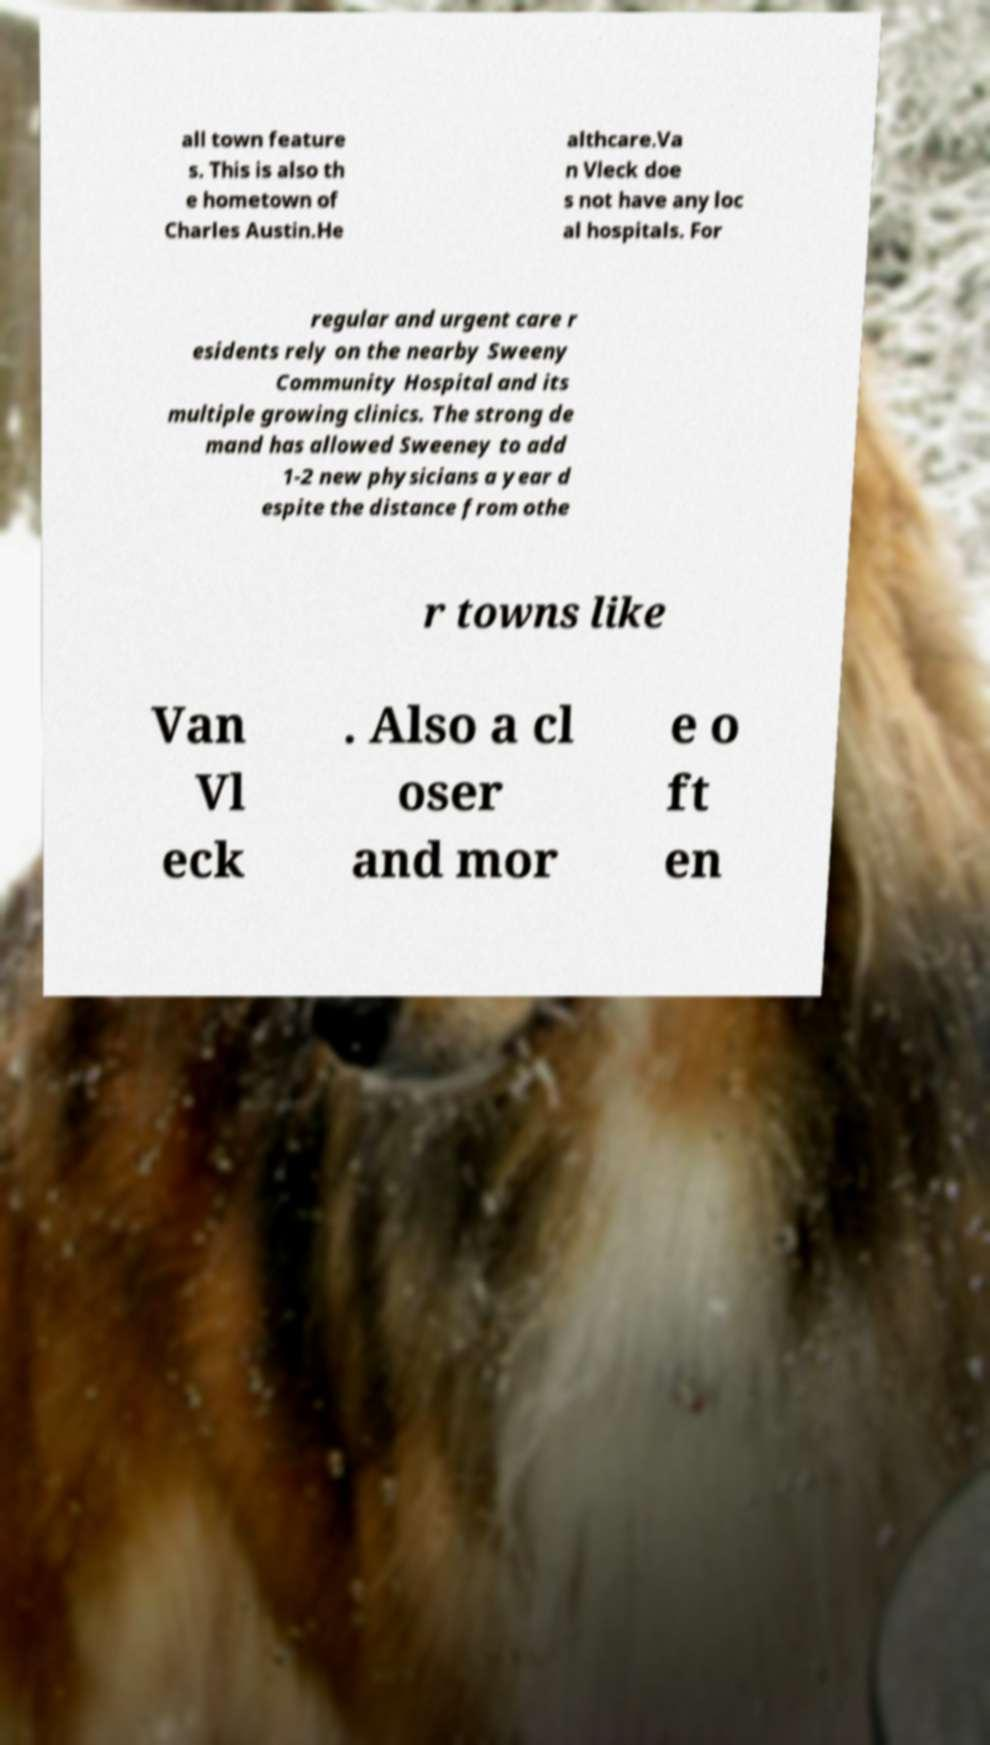I need the written content from this picture converted into text. Can you do that? all town feature s. This is also th e hometown of Charles Austin.He althcare.Va n Vleck doe s not have any loc al hospitals. For regular and urgent care r esidents rely on the nearby Sweeny Community Hospital and its multiple growing clinics. The strong de mand has allowed Sweeney to add 1-2 new physicians a year d espite the distance from othe r towns like Van Vl eck . Also a cl oser and mor e o ft en 